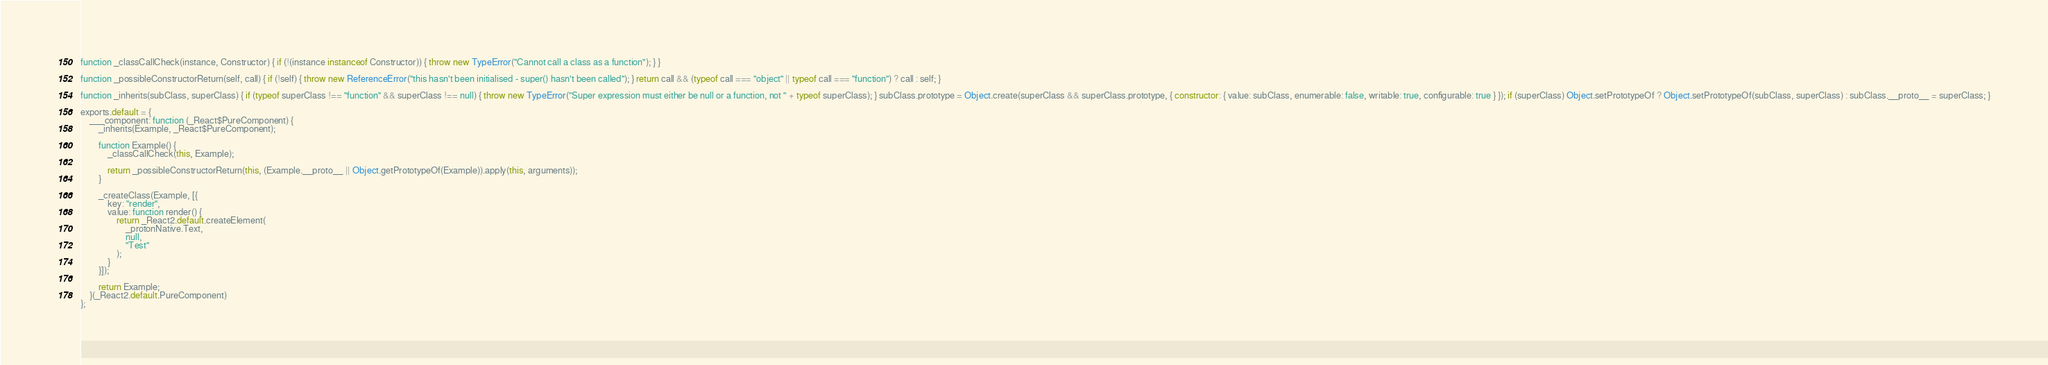Convert code to text. <code><loc_0><loc_0><loc_500><loc_500><_JavaScript_>
function _classCallCheck(instance, Constructor) { if (!(instance instanceof Constructor)) { throw new TypeError("Cannot call a class as a function"); } }

function _possibleConstructorReturn(self, call) { if (!self) { throw new ReferenceError("this hasn't been initialised - super() hasn't been called"); } return call && (typeof call === "object" || typeof call === "function") ? call : self; }

function _inherits(subClass, superClass) { if (typeof superClass !== "function" && superClass !== null) { throw new TypeError("Super expression must either be null or a function, not " + typeof superClass); } subClass.prototype = Object.create(superClass && superClass.prototype, { constructor: { value: subClass, enumerable: false, writable: true, configurable: true } }); if (superClass) Object.setPrototypeOf ? Object.setPrototypeOf(subClass, superClass) : subClass.__proto__ = superClass; }

exports.default = {
	___component: function (_React$PureComponent) {
		_inherits(Example, _React$PureComponent);

		function Example() {
			_classCallCheck(this, Example);

			return _possibleConstructorReturn(this, (Example.__proto__ || Object.getPrototypeOf(Example)).apply(this, arguments));
		}

		_createClass(Example, [{
			key: "render",
			value: function render() {
				return _React2.default.createElement(
					_protonNative.Text,
					null,
					"Test"
				);
			}
		}]);

		return Example;
	}(_React2.default.PureComponent)
};</code> 